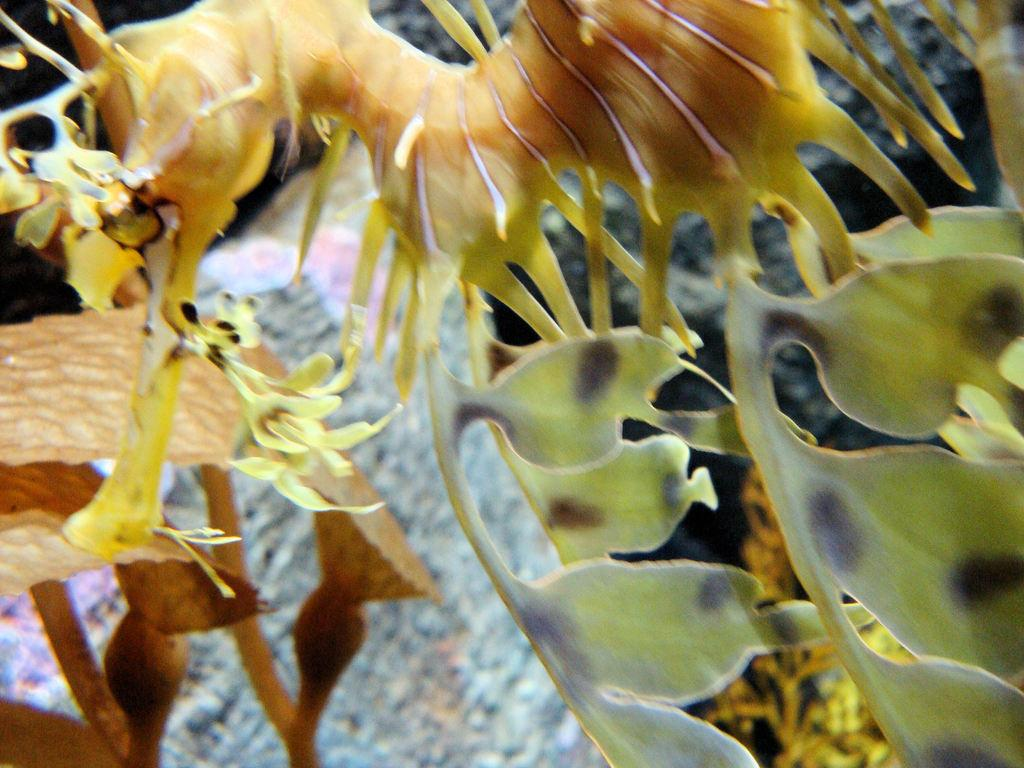How does the image demonstrate the process of digestion? The image does not demonstrate the process of digestion, as there is no information provided about the image. What is the relationship between the image and the concept of falling? There is no information provided about the image, so it is impossible to determine any relationship between the image and the concept of falling. What color are the eyes of the person in the image? There is no information provided about the image, so it is impossible to determine the color of any person's eyes in the image. 